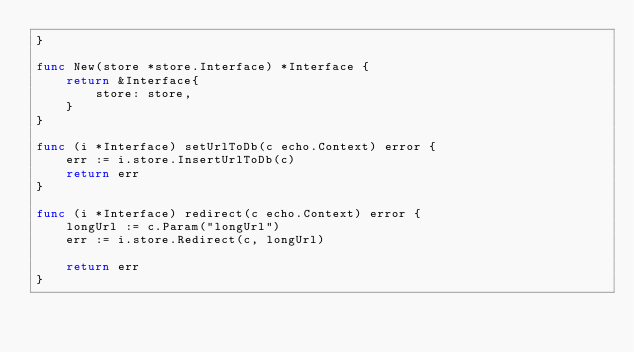Convert code to text. <code><loc_0><loc_0><loc_500><loc_500><_Go_>}

func New(store *store.Interface) *Interface {
	return &Interface{
		store: store,
	}
}

func (i *Interface) setUrlToDb(c echo.Context) error {
	err := i.store.InsertUrlToDb(c)
	return err
}

func (i *Interface) redirect(c echo.Context) error {
	longUrl := c.Param("longUrl")
	err := i.store.Redirect(c, longUrl)

	return err
}
</code> 